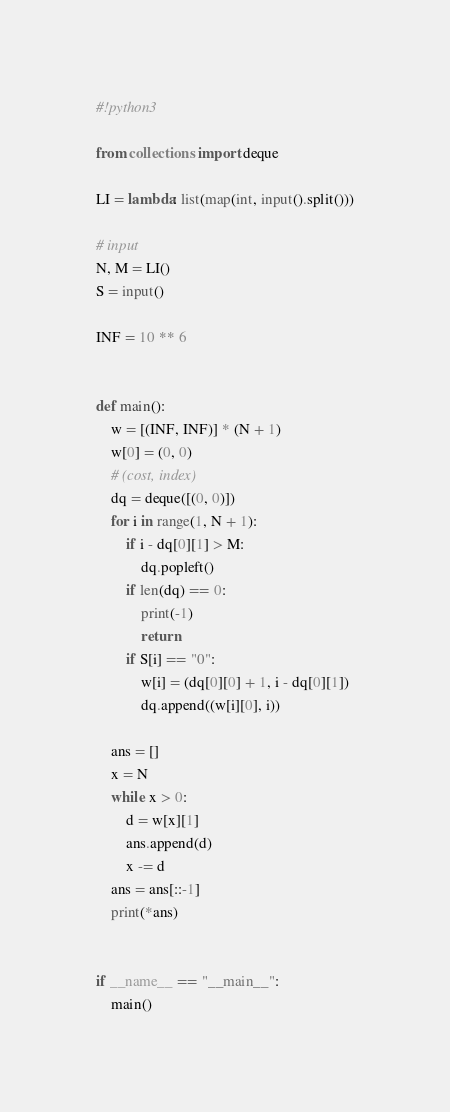<code> <loc_0><loc_0><loc_500><loc_500><_Python_>#!python3

from collections import deque

LI = lambda: list(map(int, input().split()))

# input
N, M = LI()
S = input()

INF = 10 ** 6


def main():
    w = [(INF, INF)] * (N + 1)
    w[0] = (0, 0)
    # (cost, index)
    dq = deque([(0, 0)])
    for i in range(1, N + 1):
        if i - dq[0][1] > M:
            dq.popleft()
        if len(dq) == 0:
            print(-1)
            return
        if S[i] == "0":
            w[i] = (dq[0][0] + 1, i - dq[0][1])
            dq.append((w[i][0], i))

    ans = []
    x = N
    while x > 0:
        d = w[x][1]
        ans.append(d) 
        x -= d
    ans = ans[::-1]
    print(*ans)


if __name__ == "__main__":
    main()
</code> 